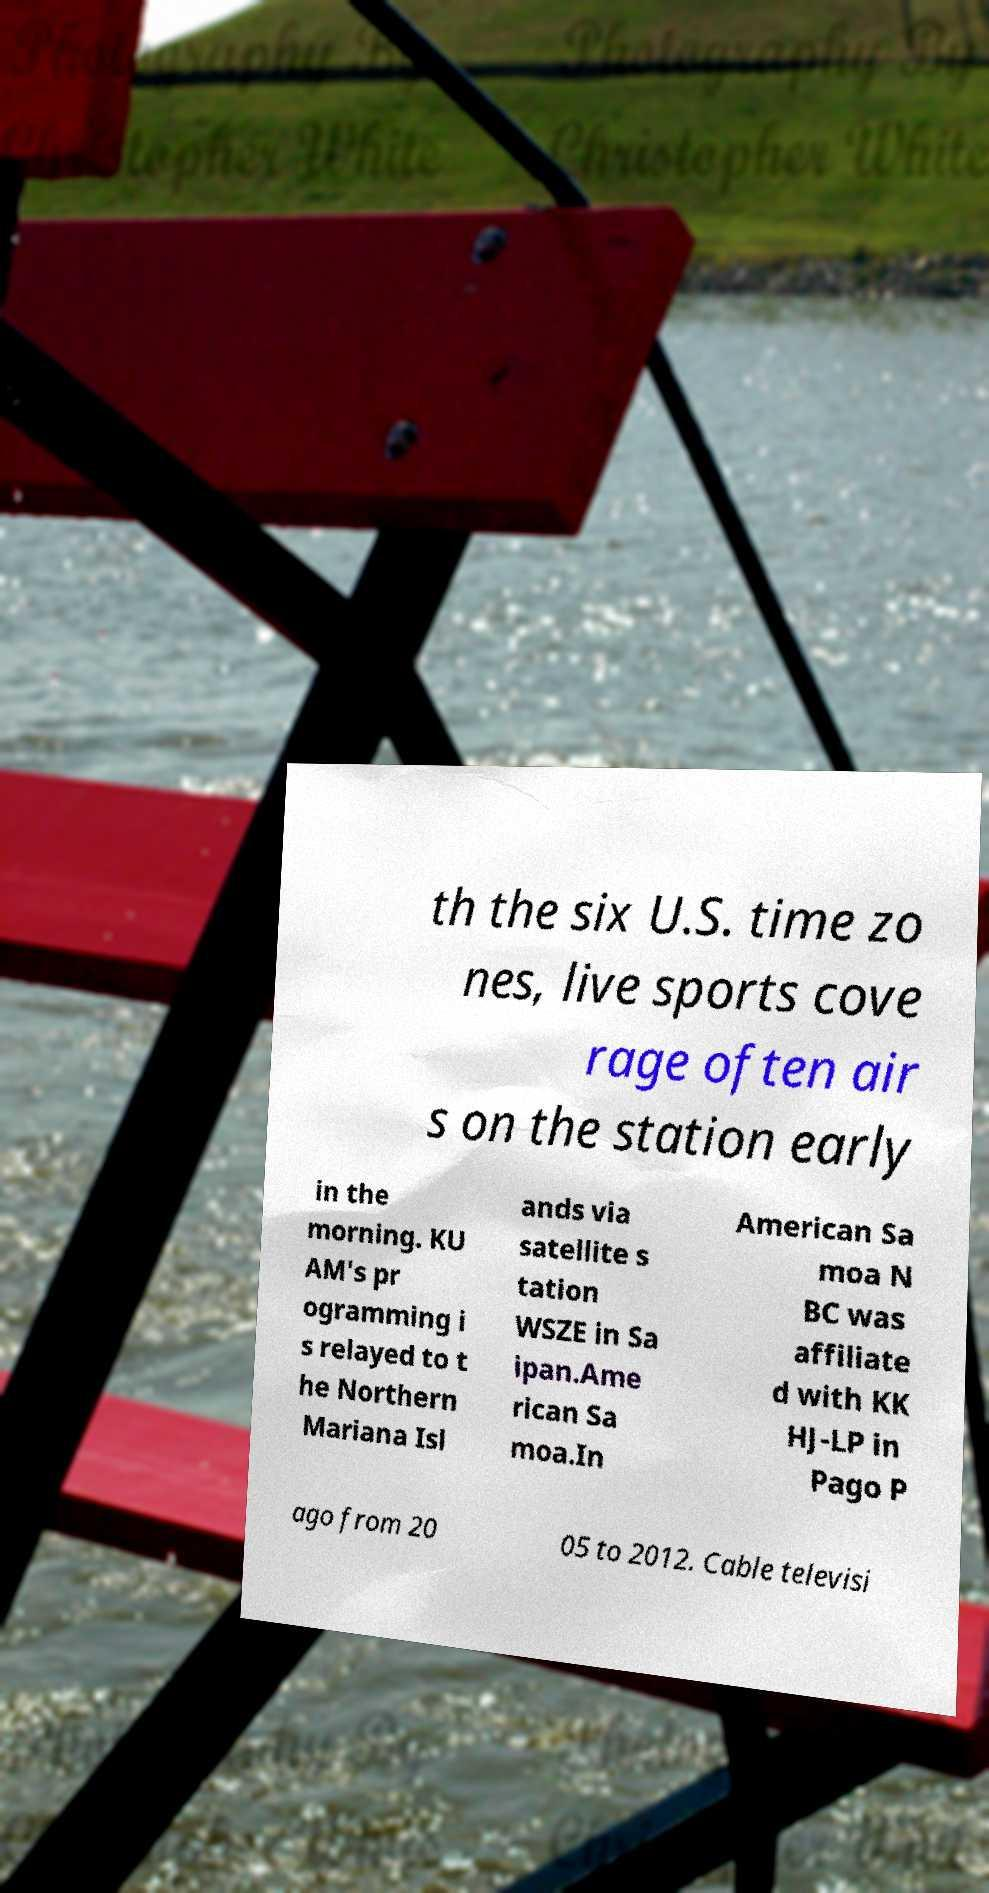For documentation purposes, I need the text within this image transcribed. Could you provide that? th the six U.S. time zo nes, live sports cove rage often air s on the station early in the morning. KU AM's pr ogramming i s relayed to t he Northern Mariana Isl ands via satellite s tation WSZE in Sa ipan.Ame rican Sa moa.In American Sa moa N BC was affiliate d with KK HJ-LP in Pago P ago from 20 05 to 2012. Cable televisi 